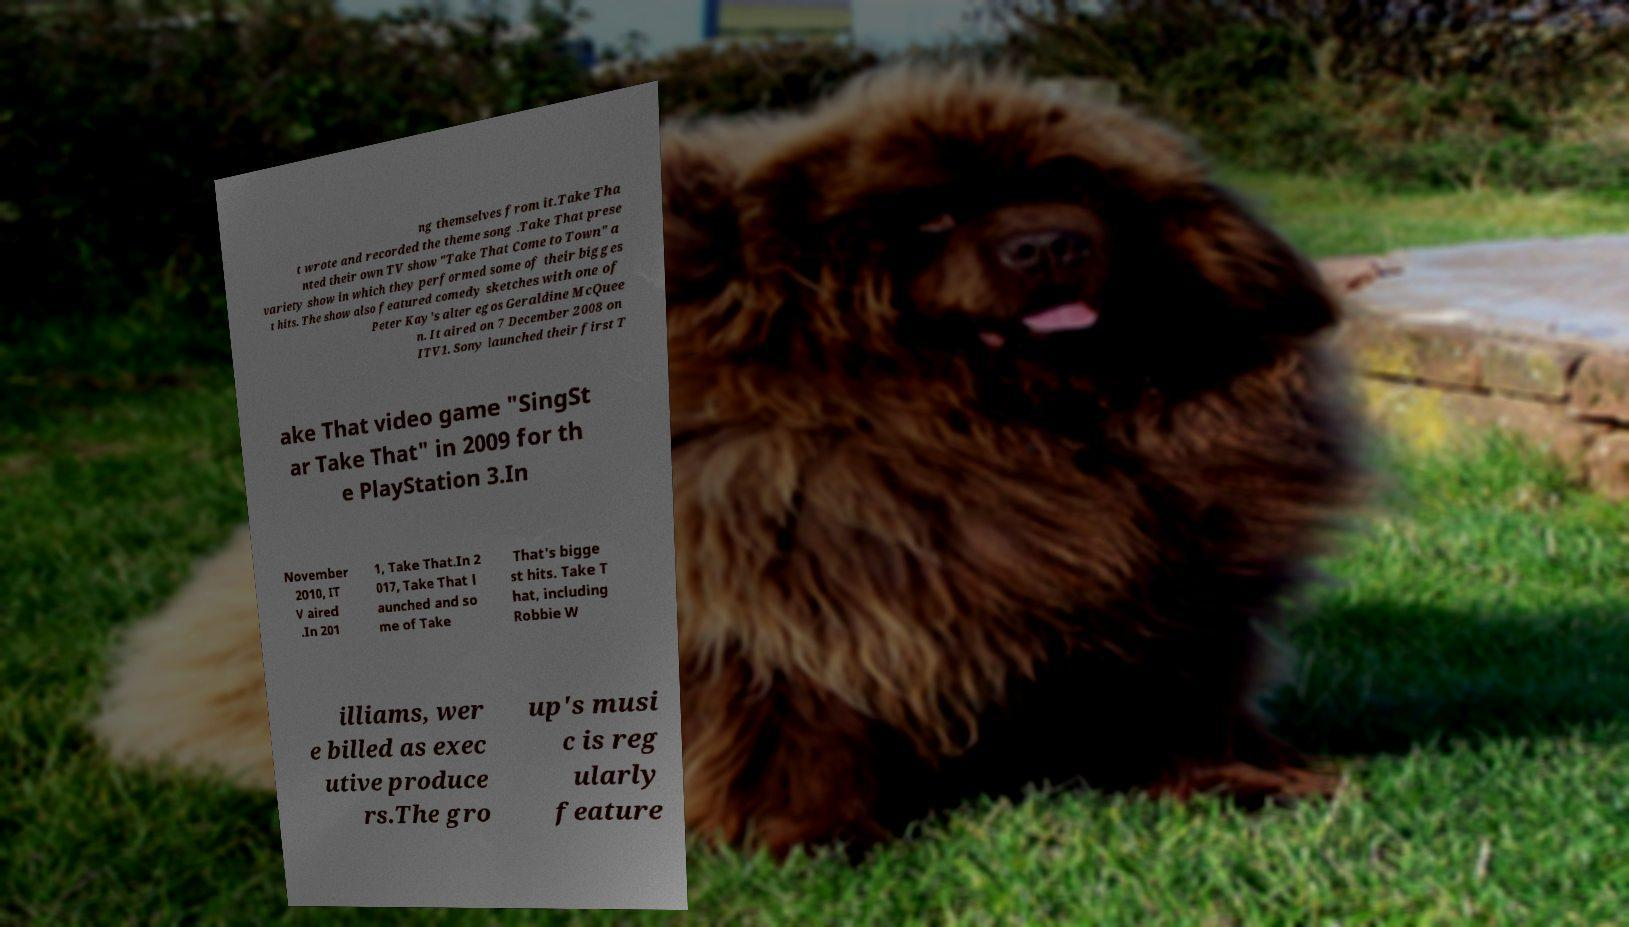What messages or text are displayed in this image? I need them in a readable, typed format. ng themselves from it.Take Tha t wrote and recorded the theme song .Take That prese nted their own TV show "Take That Come to Town" a variety show in which they performed some of their bigges t hits. The show also featured comedy sketches with one of Peter Kay's alter egos Geraldine McQuee n. It aired on 7 December 2008 on ITV1. Sony launched their first T ake That video game "SingSt ar Take That" in 2009 for th e PlayStation 3.In November 2010, IT V aired .In 201 1, Take That.In 2 017, Take That l aunched and so me of Take That's bigge st hits. Take T hat, including Robbie W illiams, wer e billed as exec utive produce rs.The gro up's musi c is reg ularly feature 